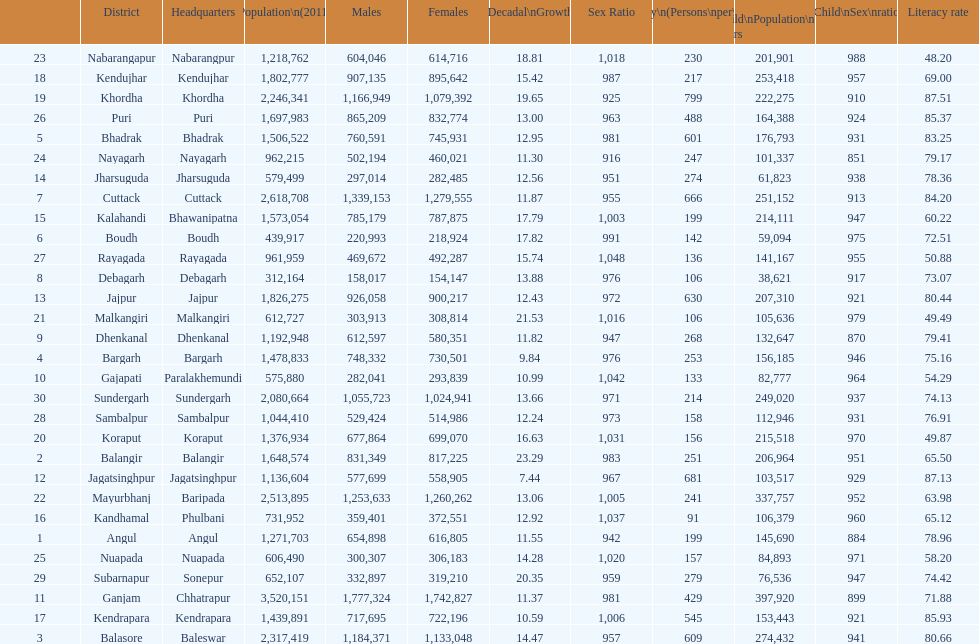Tell me a district that did not have a population over 600,000. Boudh. 